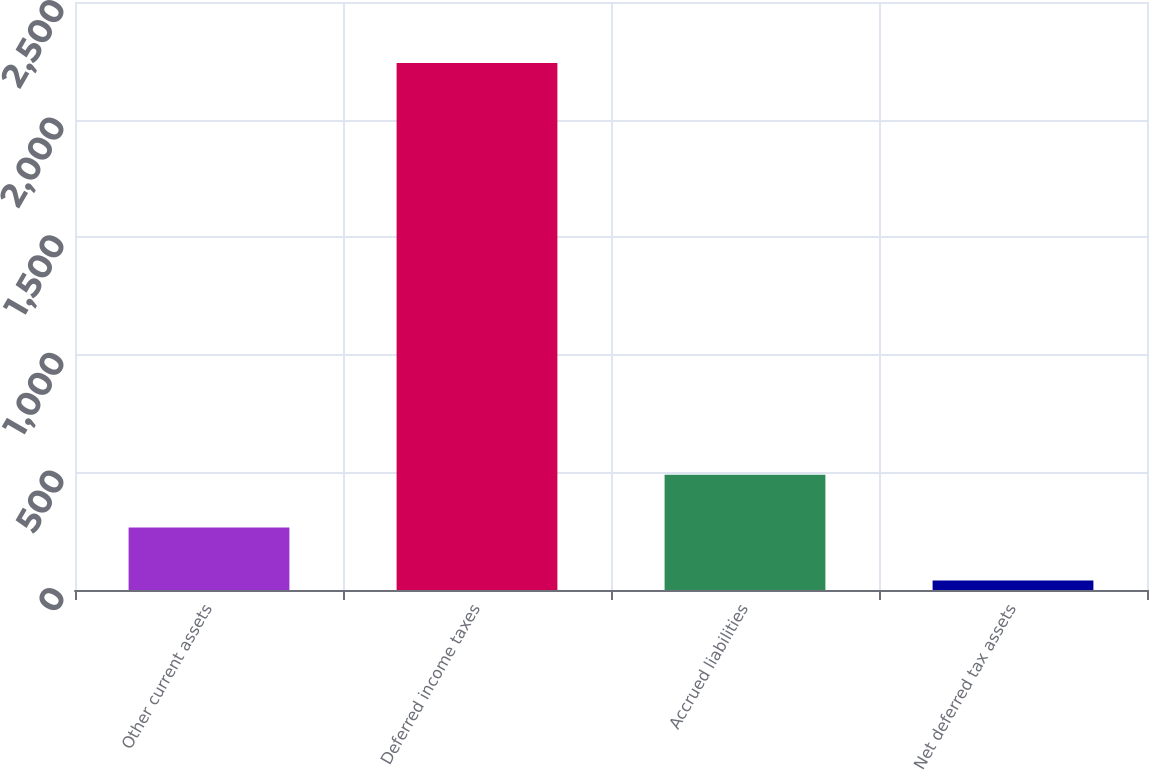Convert chart. <chart><loc_0><loc_0><loc_500><loc_500><bar_chart><fcel>Other current assets<fcel>Deferred income taxes<fcel>Accrued liabilities<fcel>Net deferred tax assets<nl><fcel>265.2<fcel>2241<fcel>490.4<fcel>40<nl></chart> 